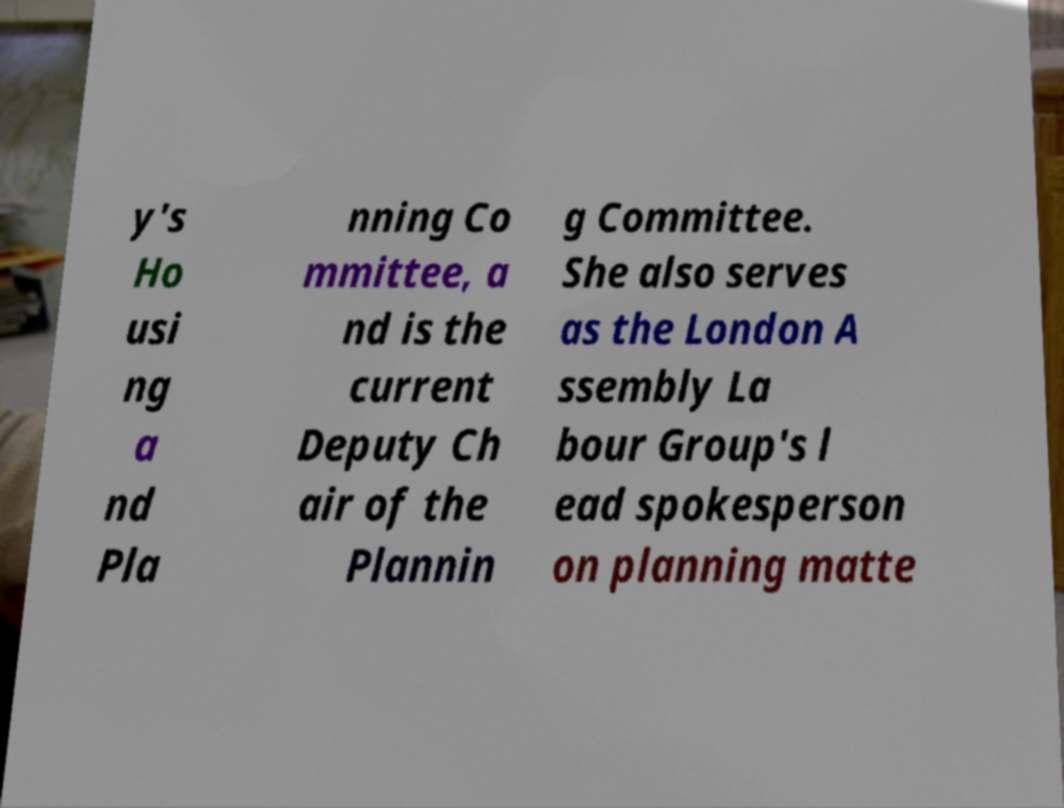Can you read and provide the text displayed in the image?This photo seems to have some interesting text. Can you extract and type it out for me? y's Ho usi ng a nd Pla nning Co mmittee, a nd is the current Deputy Ch air of the Plannin g Committee. She also serves as the London A ssembly La bour Group's l ead spokesperson on planning matte 